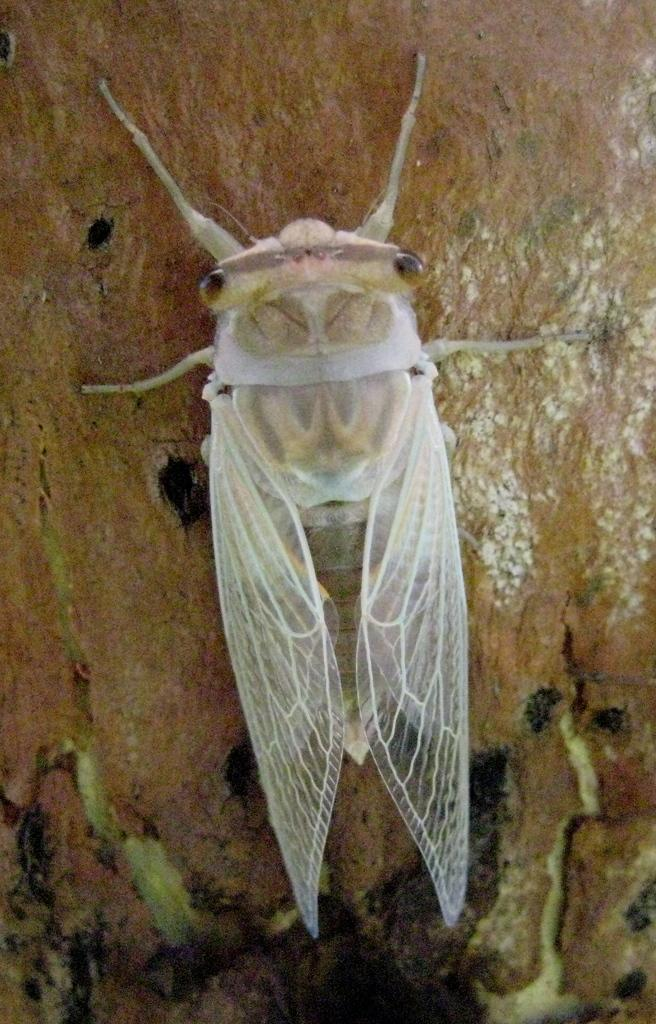What is present on the wooden surface in the image? There is an insect on the wooden surface. Can you describe the wooden surface in the image? The wooden surface is the background for the insect in the image. What type of account does the insect have in the image? There is no mention of an account or any financial aspect in the image. The image only features an insect on a wooden surface. 